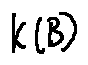Convert formula to latex. <formula><loc_0><loc_0><loc_500><loc_500>k ( B )</formula> 